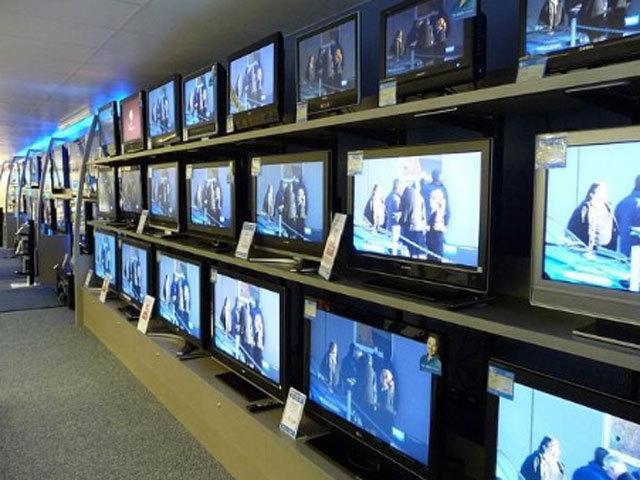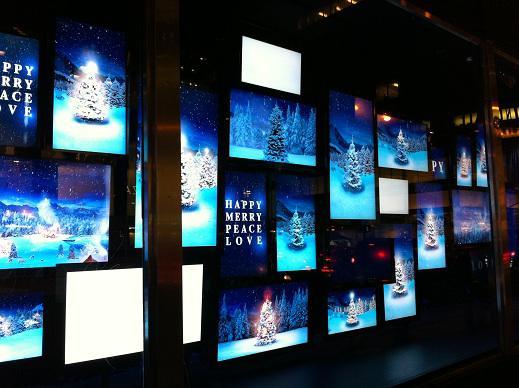The first image is the image on the left, the second image is the image on the right. Assess this claim about the two images: "there is a pile of old tv's outside in front of a brick building". Correct or not? Answer yes or no. No. The first image is the image on the left, the second image is the image on the right. Examine the images to the left and right. Is the description "The televisions in each of the images are stacked up in piles." accurate? Answer yes or no. No. 